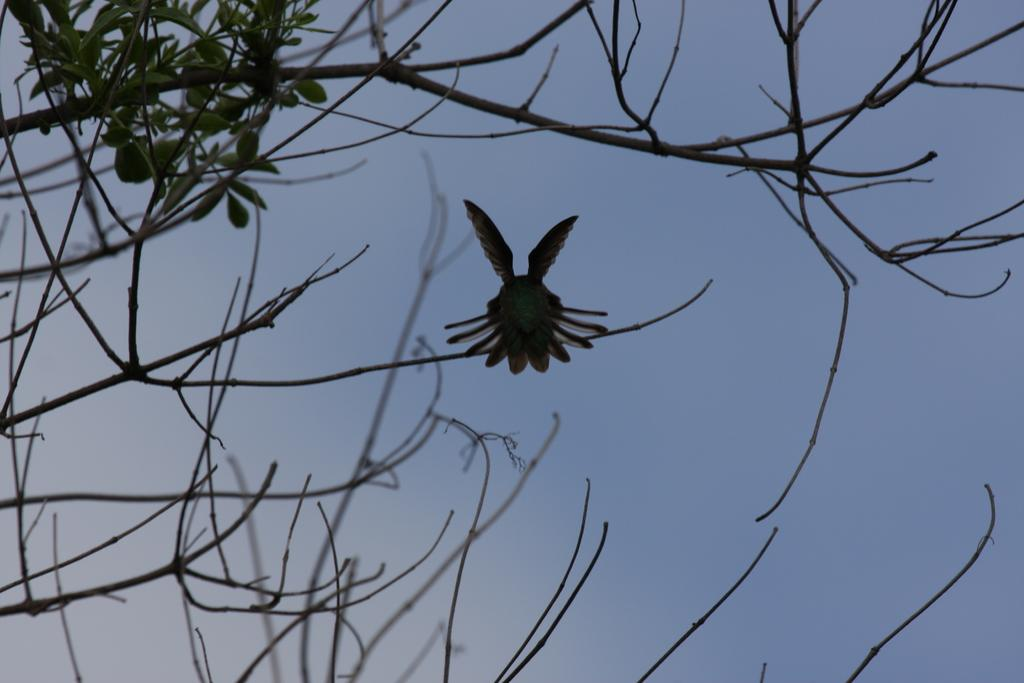What type of animal is in the image? There is a bird in the image. Where is the bird located? The bird is on a branch in the image. What is the bird sitting on? The bird is sitting on a branch of a tree in the image. What color is the sky in the image? The sky is blue in color in the image. How many tickets are visible in the image? There are no tickets present in the image. What type of plane can be seen in the image? There is no plane present in the image. 